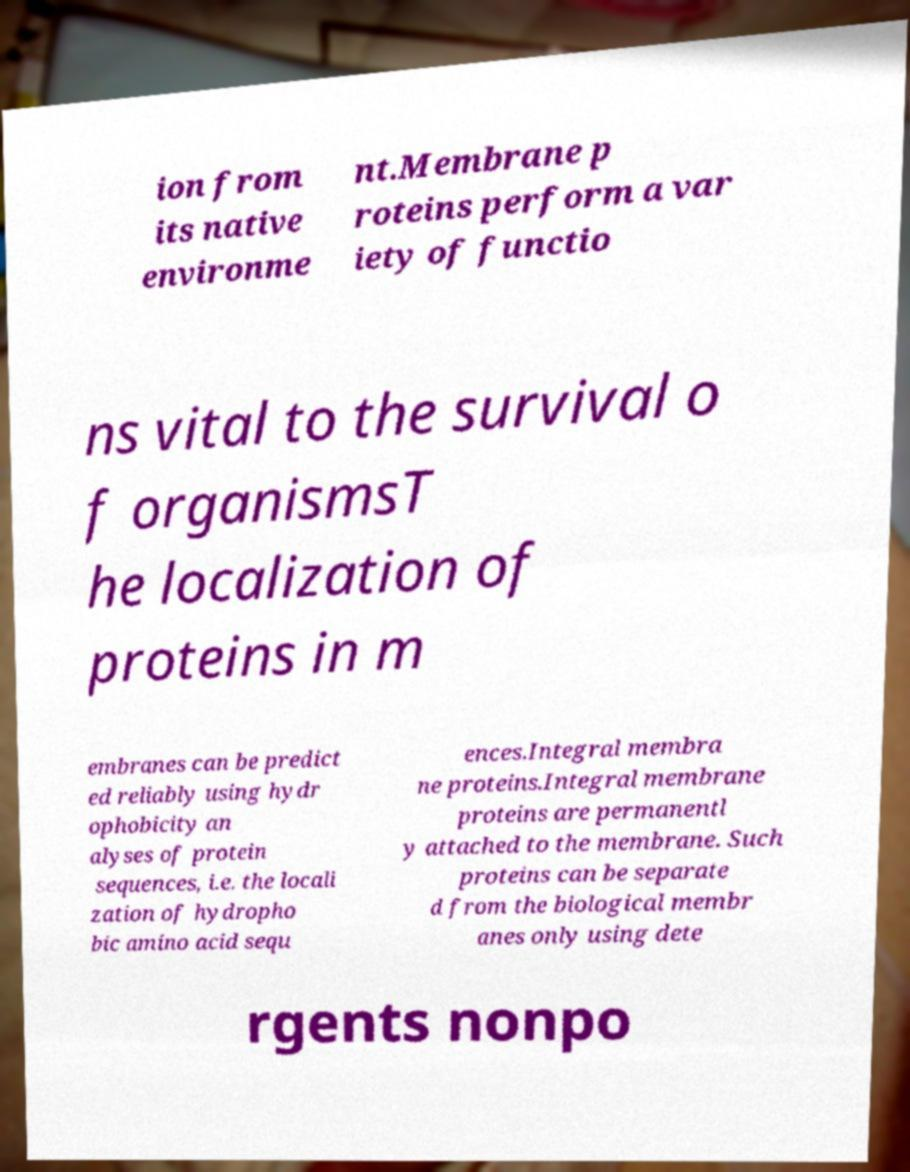For documentation purposes, I need the text within this image transcribed. Could you provide that? ion from its native environme nt.Membrane p roteins perform a var iety of functio ns vital to the survival o f organismsT he localization of proteins in m embranes can be predict ed reliably using hydr ophobicity an alyses of protein sequences, i.e. the locali zation of hydropho bic amino acid sequ ences.Integral membra ne proteins.Integral membrane proteins are permanentl y attached to the membrane. Such proteins can be separate d from the biological membr anes only using dete rgents nonpo 